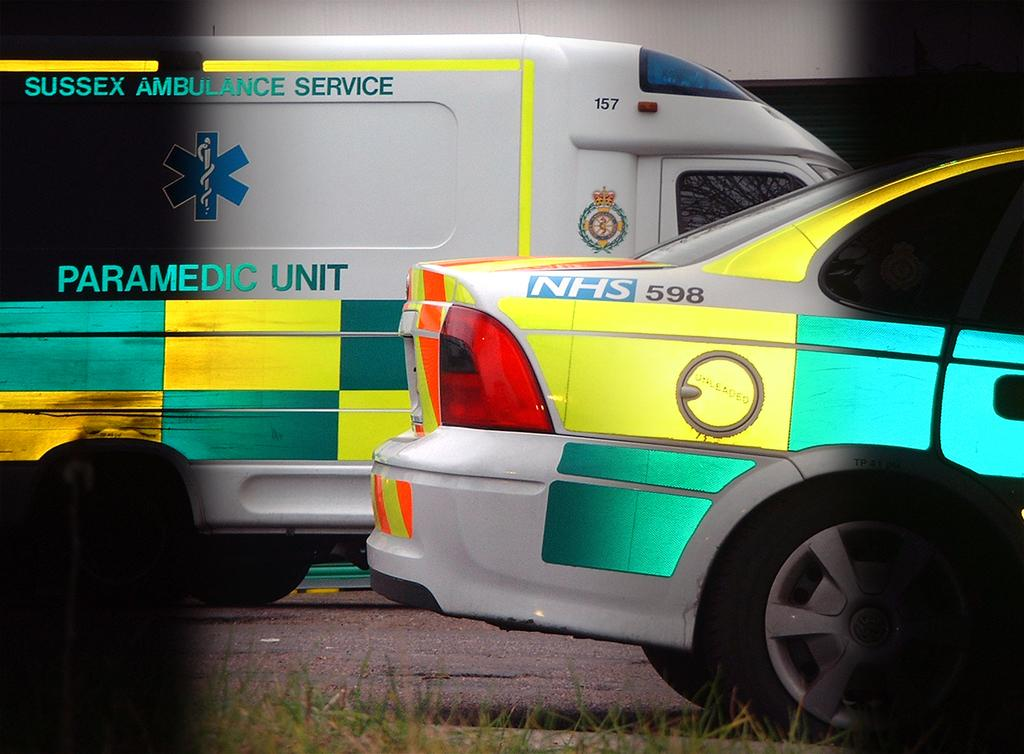<image>
Render a clear and concise summary of the photo. Ambulance from Sussex Ambulance Service Paramedic Unit next to an offical vehicle NHS 598. 